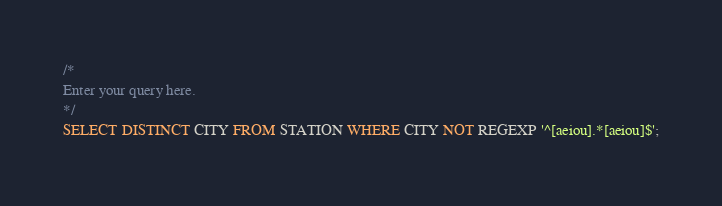<code> <loc_0><loc_0><loc_500><loc_500><_SQL_>/*
Enter your query here.
*/
SELECT DISTINCT CITY FROM STATION WHERE CITY NOT REGEXP '^[aeiou].*[aeiou]$';</code> 